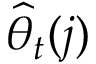Convert formula to latex. <formula><loc_0><loc_0><loc_500><loc_500>\widehat { \theta } _ { t } ( j )</formula> 